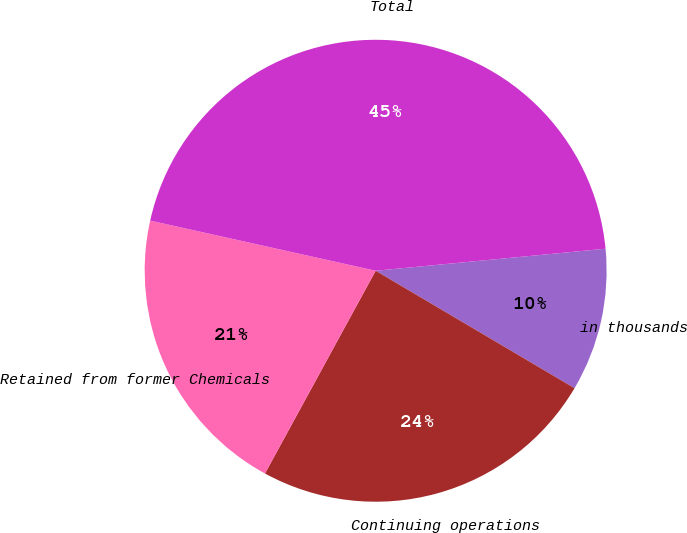<chart> <loc_0><loc_0><loc_500><loc_500><pie_chart><fcel>in thousands<fcel>Continuing operations<fcel>Retained from former Chemicals<fcel>Total<nl><fcel>10.01%<fcel>24.46%<fcel>20.53%<fcel>44.99%<nl></chart> 